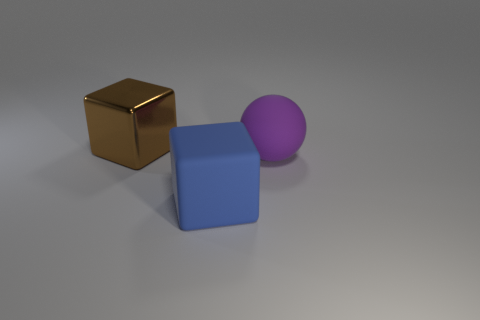Is the shape of the brown shiny thing the same as the purple object?
Offer a terse response. No. Is the size of the purple sphere the same as the metallic block?
Provide a succinct answer. Yes. Does the blue thing have the same size as the block behind the large sphere?
Provide a succinct answer. Yes. Are there any other things that have the same shape as the big purple rubber object?
Your response must be concise. No. Is the large object to the right of the blue rubber thing made of the same material as the big brown object?
Your answer should be very brief. No. What material is the large purple object?
Make the answer very short. Rubber. There is a block in front of the large brown metallic block; how big is it?
Give a very brief answer. Large. There is a big rubber object that is in front of the purple matte object; how many big blue rubber objects are behind it?
Ensure brevity in your answer.  0. There is a matte thing that is in front of the big purple thing; is it the same shape as the big thing that is on the left side of the big blue rubber object?
Offer a very short reply. Yes. What number of blocks are in front of the large metal thing and left of the blue rubber object?
Your response must be concise. 0. 